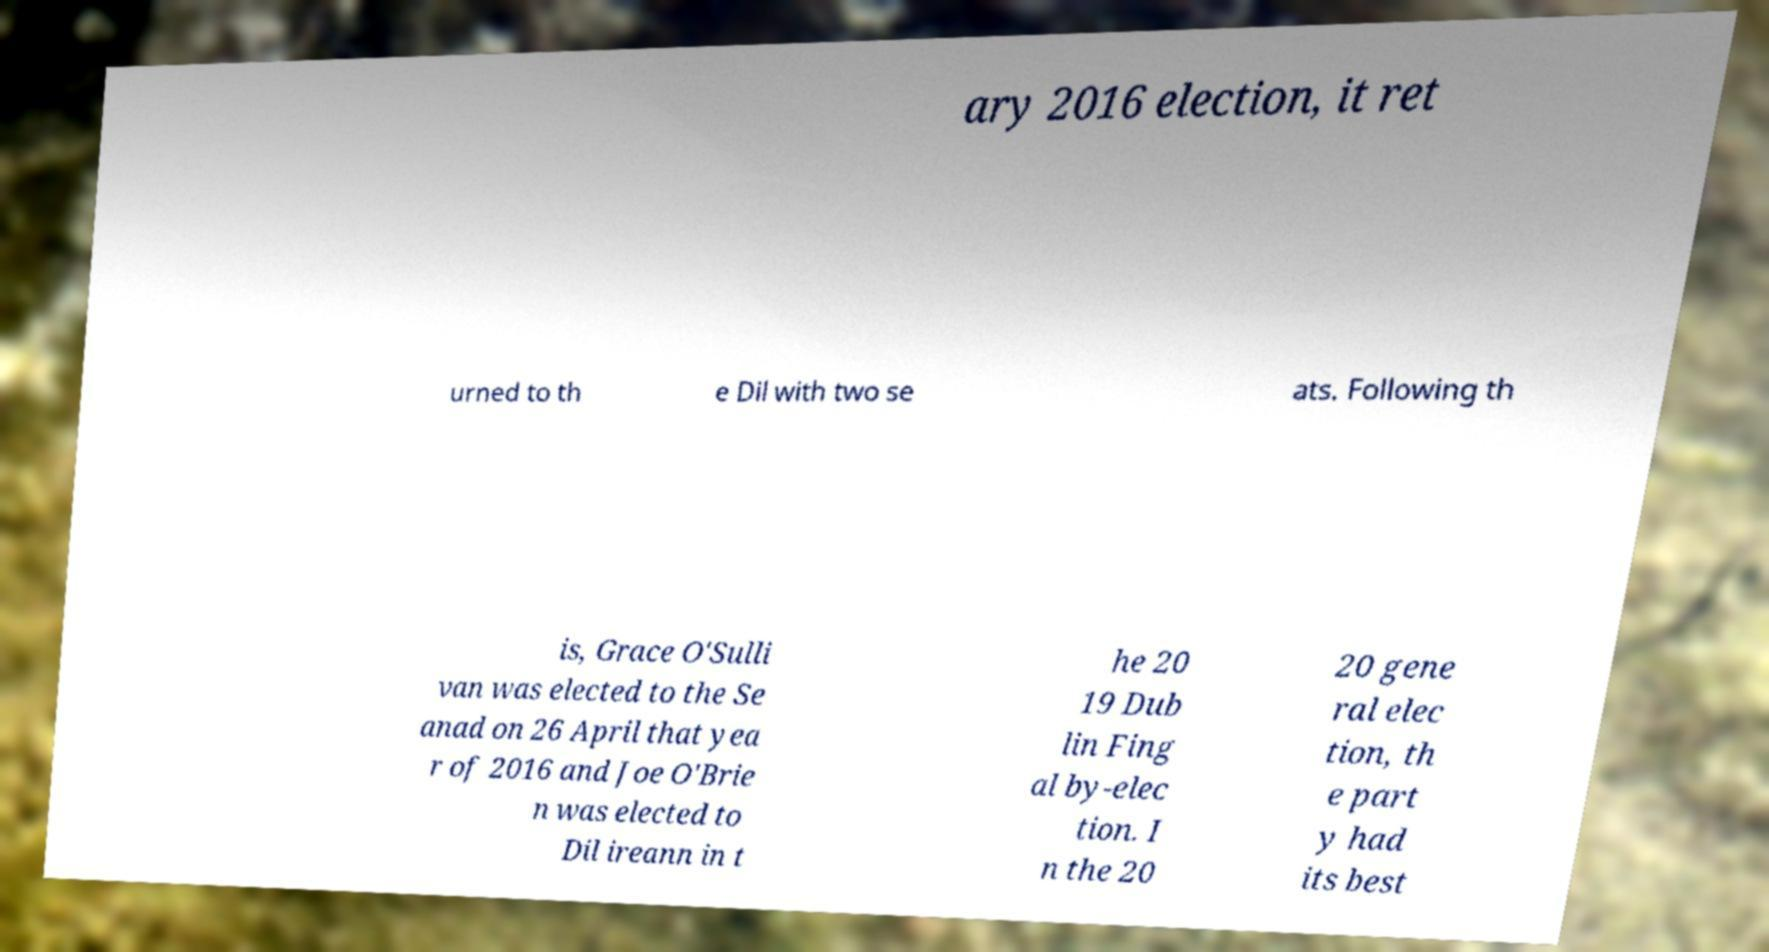Please identify and transcribe the text found in this image. ary 2016 election, it ret urned to th e Dil with two se ats. Following th is, Grace O'Sulli van was elected to the Se anad on 26 April that yea r of 2016 and Joe O'Brie n was elected to Dil ireann in t he 20 19 Dub lin Fing al by-elec tion. I n the 20 20 gene ral elec tion, th e part y had its best 